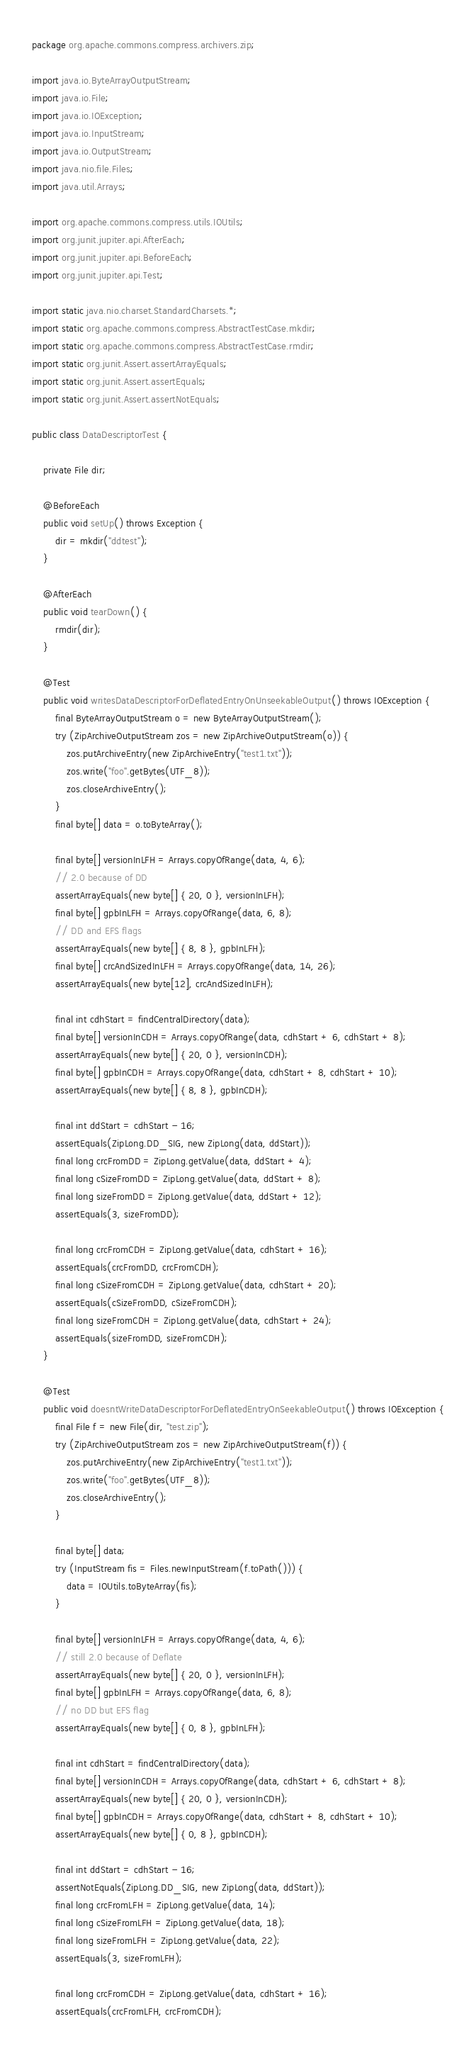<code> <loc_0><loc_0><loc_500><loc_500><_Java_>package org.apache.commons.compress.archivers.zip;

import java.io.ByteArrayOutputStream;
import java.io.File;
import java.io.IOException;
import java.io.InputStream;
import java.io.OutputStream;
import java.nio.file.Files;
import java.util.Arrays;

import org.apache.commons.compress.utils.IOUtils;
import org.junit.jupiter.api.AfterEach;
import org.junit.jupiter.api.BeforeEach;
import org.junit.jupiter.api.Test;

import static java.nio.charset.StandardCharsets.*;
import static org.apache.commons.compress.AbstractTestCase.mkdir;
import static org.apache.commons.compress.AbstractTestCase.rmdir;
import static org.junit.Assert.assertArrayEquals;
import static org.junit.Assert.assertEquals;
import static org.junit.Assert.assertNotEquals;

public class DataDescriptorTest {

    private File dir;

    @BeforeEach
    public void setUp() throws Exception {
        dir = mkdir("ddtest");
    }

    @AfterEach
    public void tearDown() {
        rmdir(dir);
    }

    @Test
    public void writesDataDescriptorForDeflatedEntryOnUnseekableOutput() throws IOException {
        final ByteArrayOutputStream o = new ByteArrayOutputStream();
        try (ZipArchiveOutputStream zos = new ZipArchiveOutputStream(o)) {
            zos.putArchiveEntry(new ZipArchiveEntry("test1.txt"));
            zos.write("foo".getBytes(UTF_8));
            zos.closeArchiveEntry();
        }
        final byte[] data = o.toByteArray();

        final byte[] versionInLFH = Arrays.copyOfRange(data, 4, 6);
        // 2.0 because of DD
        assertArrayEquals(new byte[] { 20, 0 }, versionInLFH);
        final byte[] gpbInLFH = Arrays.copyOfRange(data, 6, 8);
        // DD and EFS flags
        assertArrayEquals(new byte[] { 8, 8 }, gpbInLFH);
        final byte[] crcAndSizedInLFH = Arrays.copyOfRange(data, 14, 26);
        assertArrayEquals(new byte[12], crcAndSizedInLFH);

        final int cdhStart = findCentralDirectory(data);
        final byte[] versionInCDH = Arrays.copyOfRange(data, cdhStart + 6, cdhStart + 8);
        assertArrayEquals(new byte[] { 20, 0 }, versionInCDH);
        final byte[] gpbInCDH = Arrays.copyOfRange(data, cdhStart + 8, cdhStart + 10);
        assertArrayEquals(new byte[] { 8, 8 }, gpbInCDH);

        final int ddStart = cdhStart - 16;
        assertEquals(ZipLong.DD_SIG, new ZipLong(data, ddStart));
        final long crcFromDD = ZipLong.getValue(data, ddStart + 4);
        final long cSizeFromDD = ZipLong.getValue(data, ddStart + 8);
        final long sizeFromDD = ZipLong.getValue(data, ddStart + 12);
        assertEquals(3, sizeFromDD);

        final long crcFromCDH = ZipLong.getValue(data, cdhStart + 16);
        assertEquals(crcFromDD, crcFromCDH);
        final long cSizeFromCDH = ZipLong.getValue(data, cdhStart + 20);
        assertEquals(cSizeFromDD, cSizeFromCDH);
        final long sizeFromCDH = ZipLong.getValue(data, cdhStart + 24);
        assertEquals(sizeFromDD, sizeFromCDH);
    }

    @Test
    public void doesntWriteDataDescriptorForDeflatedEntryOnSeekableOutput() throws IOException {
        final File f = new File(dir, "test.zip");
        try (ZipArchiveOutputStream zos = new ZipArchiveOutputStream(f)) {
            zos.putArchiveEntry(new ZipArchiveEntry("test1.txt"));
            zos.write("foo".getBytes(UTF_8));
            zos.closeArchiveEntry();
        }

        final byte[] data;
        try (InputStream fis = Files.newInputStream(f.toPath())) {
            data = IOUtils.toByteArray(fis);
        }

        final byte[] versionInLFH = Arrays.copyOfRange(data, 4, 6);
        // still 2.0 because of Deflate
        assertArrayEquals(new byte[] { 20, 0 }, versionInLFH);
        final byte[] gpbInLFH = Arrays.copyOfRange(data, 6, 8);
        // no DD but EFS flag
        assertArrayEquals(new byte[] { 0, 8 }, gpbInLFH);

        final int cdhStart = findCentralDirectory(data);
        final byte[] versionInCDH = Arrays.copyOfRange(data, cdhStart + 6, cdhStart + 8);
        assertArrayEquals(new byte[] { 20, 0 }, versionInCDH);
        final byte[] gpbInCDH = Arrays.copyOfRange(data, cdhStart + 8, cdhStart + 10);
        assertArrayEquals(new byte[] { 0, 8 }, gpbInCDH);

        final int ddStart = cdhStart - 16;
        assertNotEquals(ZipLong.DD_SIG, new ZipLong(data, ddStart));
        final long crcFromLFH = ZipLong.getValue(data, 14);
        final long cSizeFromLFH = ZipLong.getValue(data, 18);
        final long sizeFromLFH = ZipLong.getValue(data, 22);
        assertEquals(3, sizeFromLFH);

        final long crcFromCDH = ZipLong.getValue(data, cdhStart + 16);
        assertEquals(crcFromLFH, crcFromCDH);</code> 